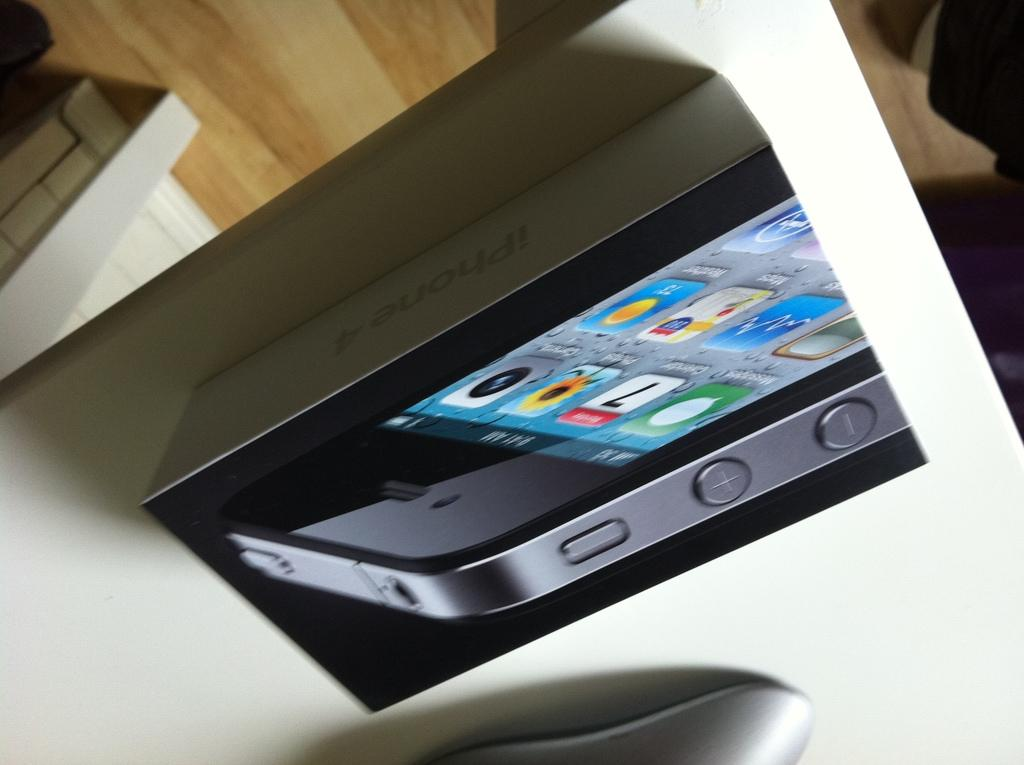<image>
Create a compact narrative representing the image presented. An upside down picture of an iPhone 4 box on a desk. 